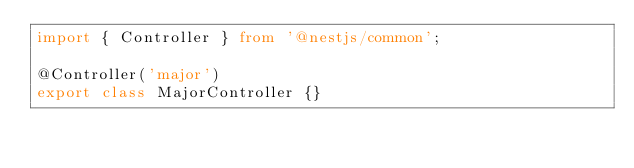Convert code to text. <code><loc_0><loc_0><loc_500><loc_500><_TypeScript_>import { Controller } from '@nestjs/common';

@Controller('major')
export class MajorController {}
</code> 